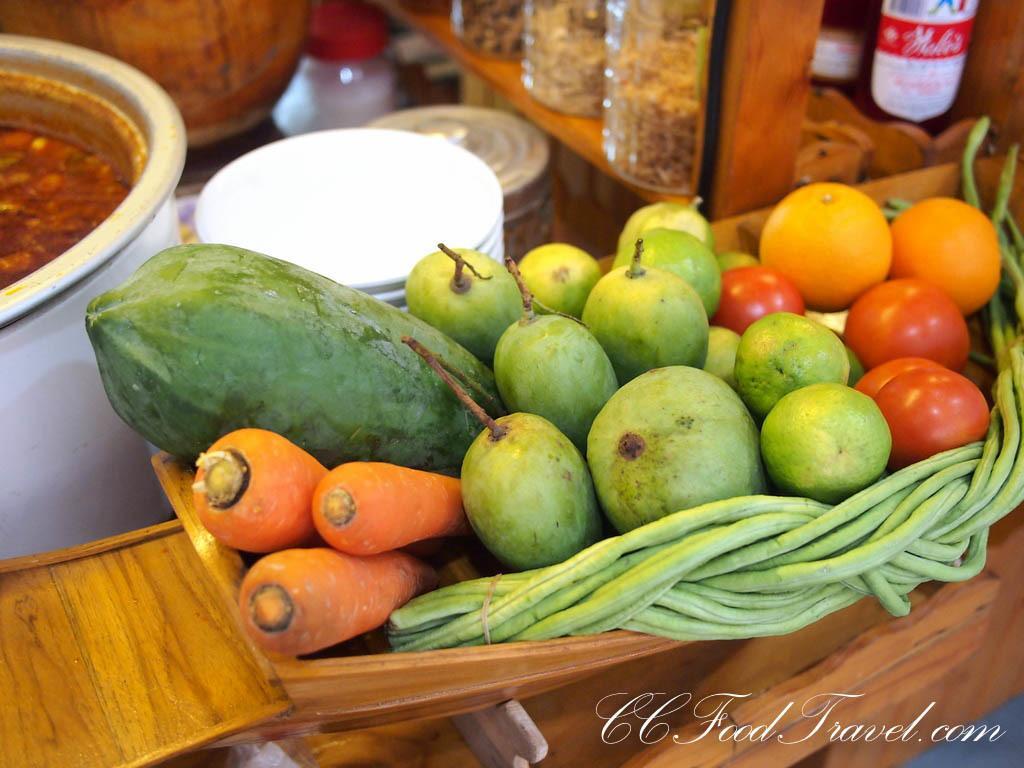How would you summarize this image in a sentence or two? This image consists of vegetables kept in a basket. To the left, there is a bowl. In the background, there are jars and boxes kept on the table. The table is made up of wood. 